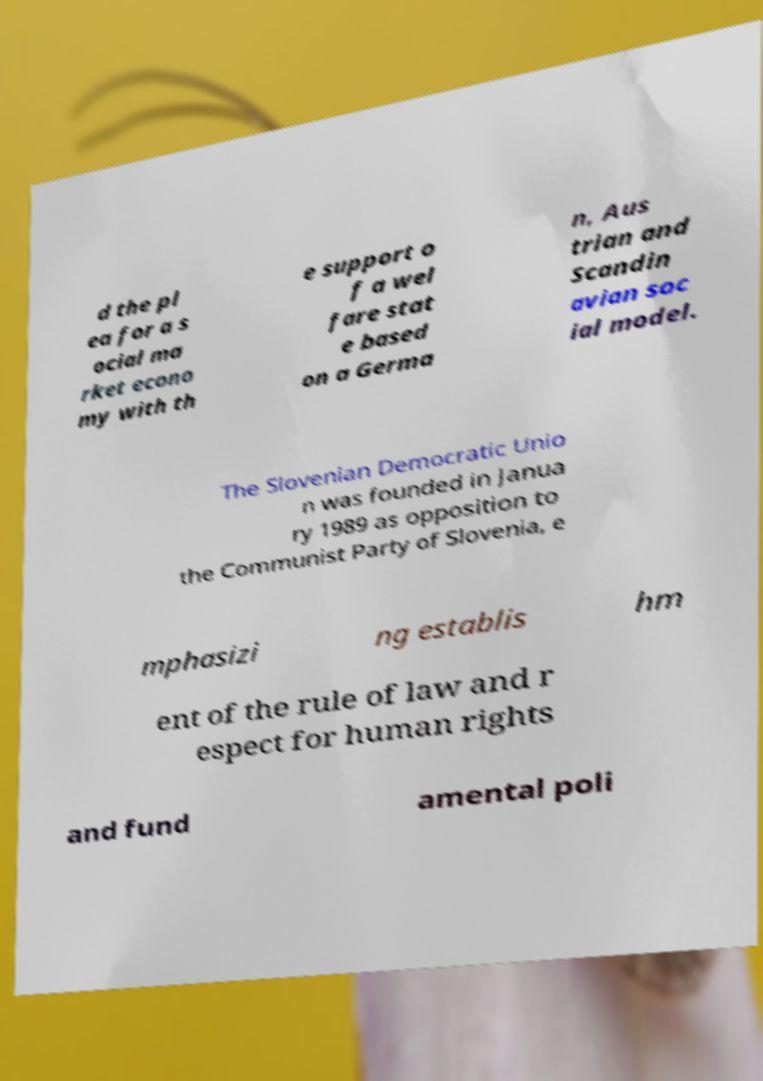For documentation purposes, I need the text within this image transcribed. Could you provide that? d the pl ea for a s ocial ma rket econo my with th e support o f a wel fare stat e based on a Germa n, Aus trian and Scandin avian soc ial model. The Slovenian Democratic Unio n was founded in Janua ry 1989 as opposition to the Communist Party of Slovenia, e mphasizi ng establis hm ent of the rule of law and r espect for human rights and fund amental poli 